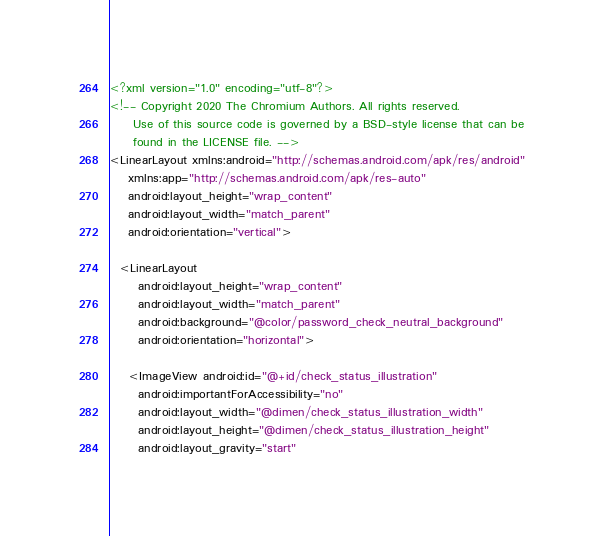Convert code to text. <code><loc_0><loc_0><loc_500><loc_500><_XML_><?xml version="1.0" encoding="utf-8"?>
<!-- Copyright 2020 The Chromium Authors. All rights reserved.
     Use of this source code is governed by a BSD-style license that can be
     found in the LICENSE file. -->
<LinearLayout xmlns:android="http://schemas.android.com/apk/res/android"
    xmlns:app="http://schemas.android.com/apk/res-auto"
    android:layout_height="wrap_content"
    android:layout_width="match_parent"
    android:orientation="vertical">

  <LinearLayout
      android:layout_height="wrap_content"
      android:layout_width="match_parent"
      android:background="@color/password_check_neutral_background"
      android:orientation="horizontal">

    <ImageView android:id="@+id/check_status_illustration"
      android:importantForAccessibility="no"
      android:layout_width="@dimen/check_status_illustration_width"
      android:layout_height="@dimen/check_status_illustration_height"
      android:layout_gravity="start"</code> 